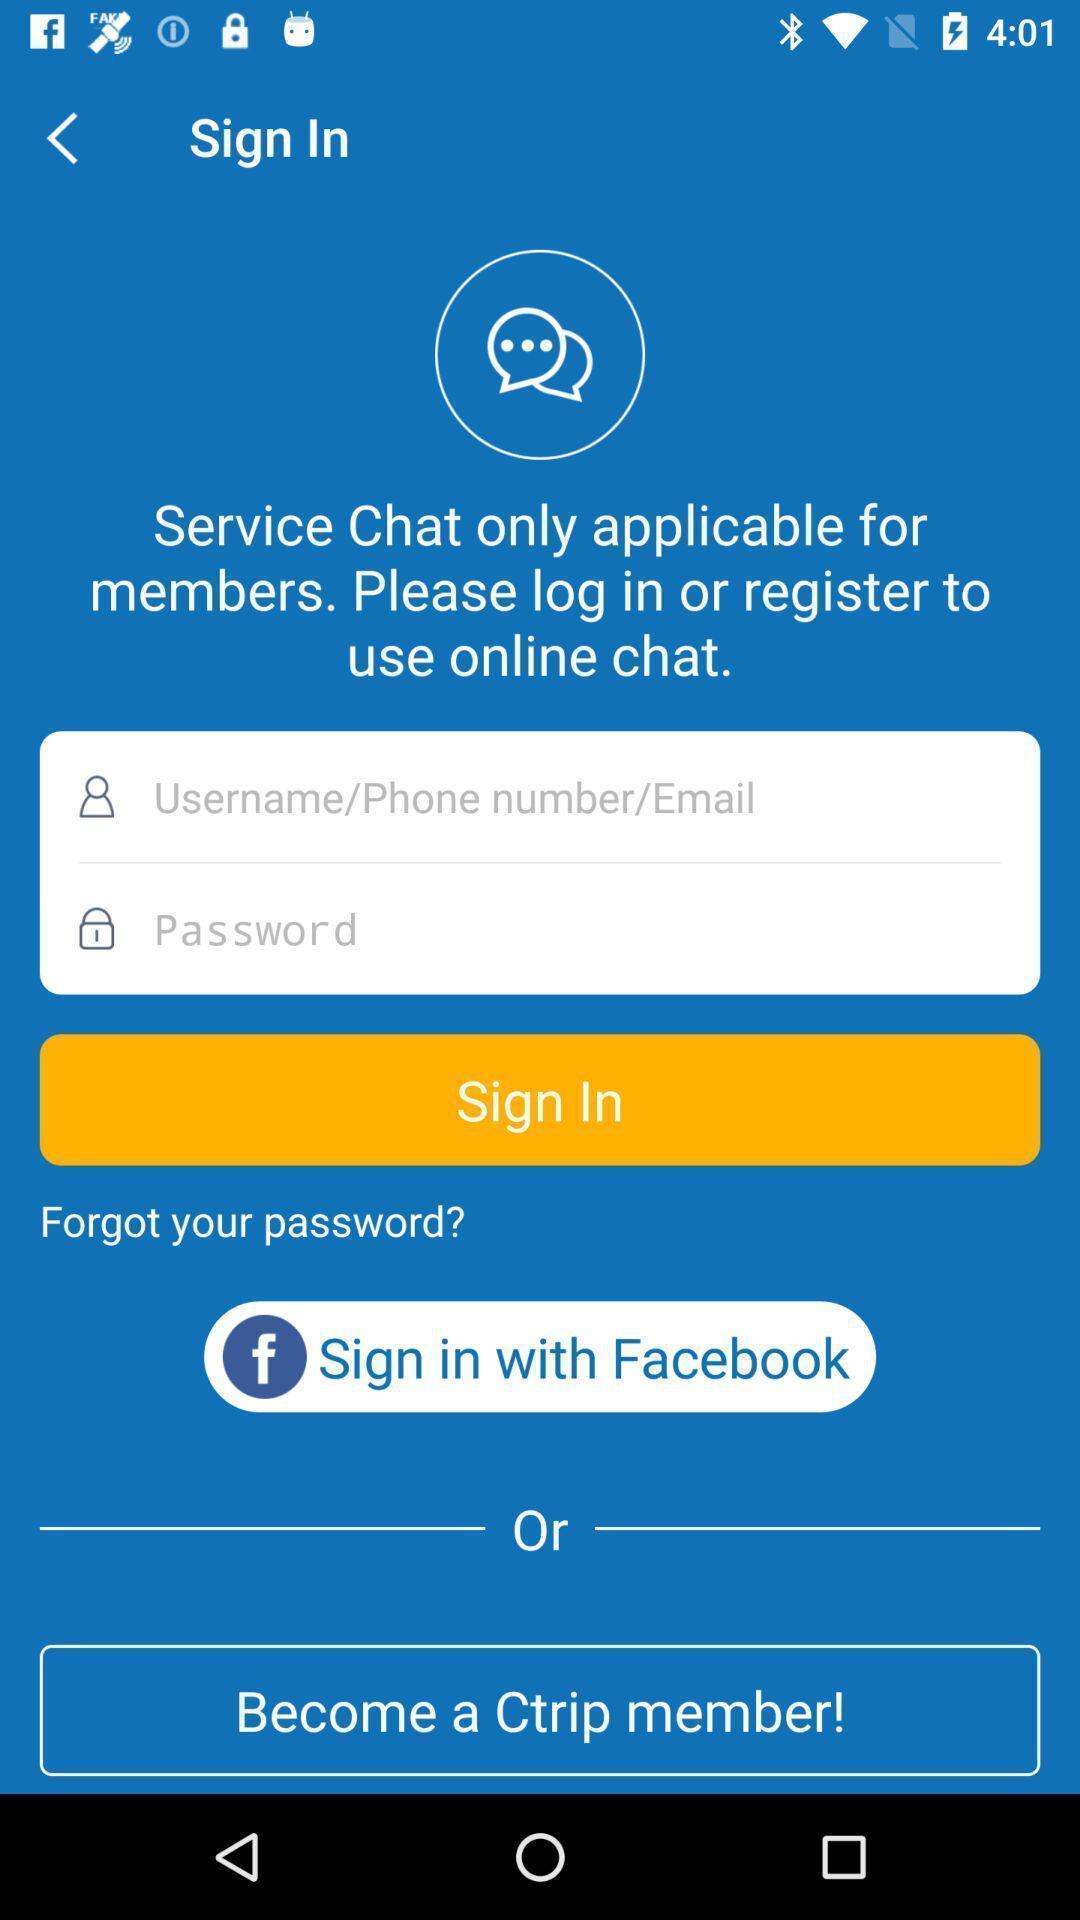Describe this image in words. Welcome page of a social app. 